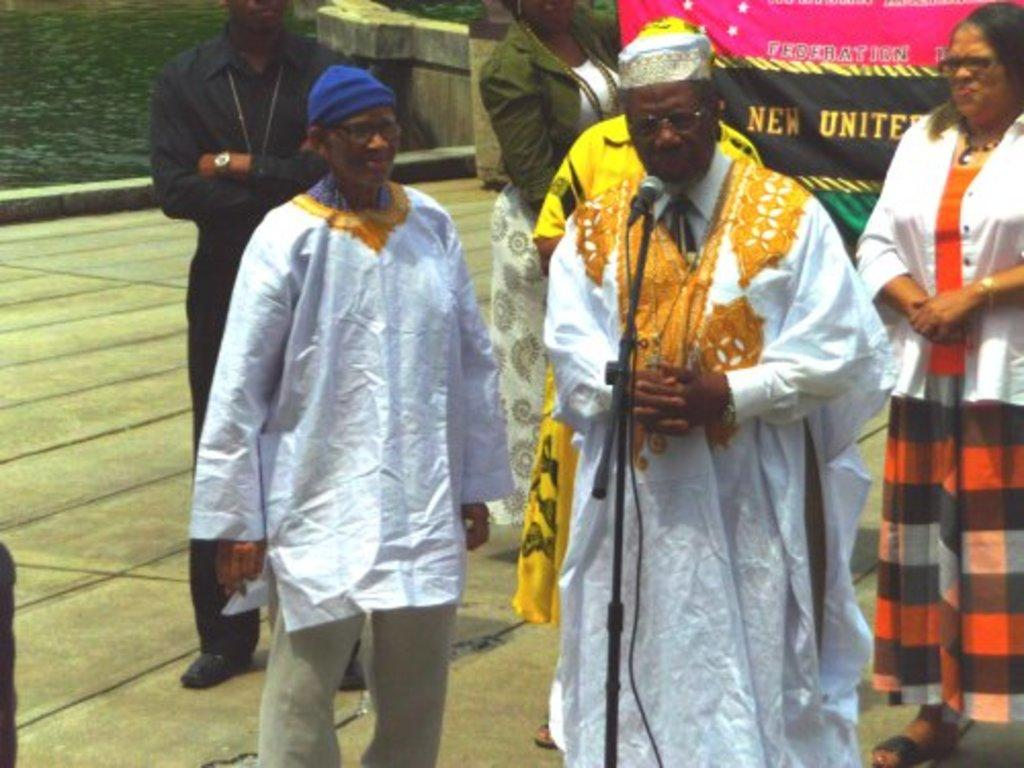What is happening in the image involving the people? There are people standing in the image, but their specific actions are not clear. What object is present for amplifying sound? There is a microphone on a stand in the image. What message or information is displayed on the banner? There is a banner with text in the image, but the specific message is not legible. What natural element can be seen in the top left corner of the image? Water is visible in the top left corner of the image. What is the distance between the store and the people in the image? There is no store present in the image, so it is not possible to determine the distance between a store and the people. What type of alarm is being used in the image? There is no alarm present in the image. 